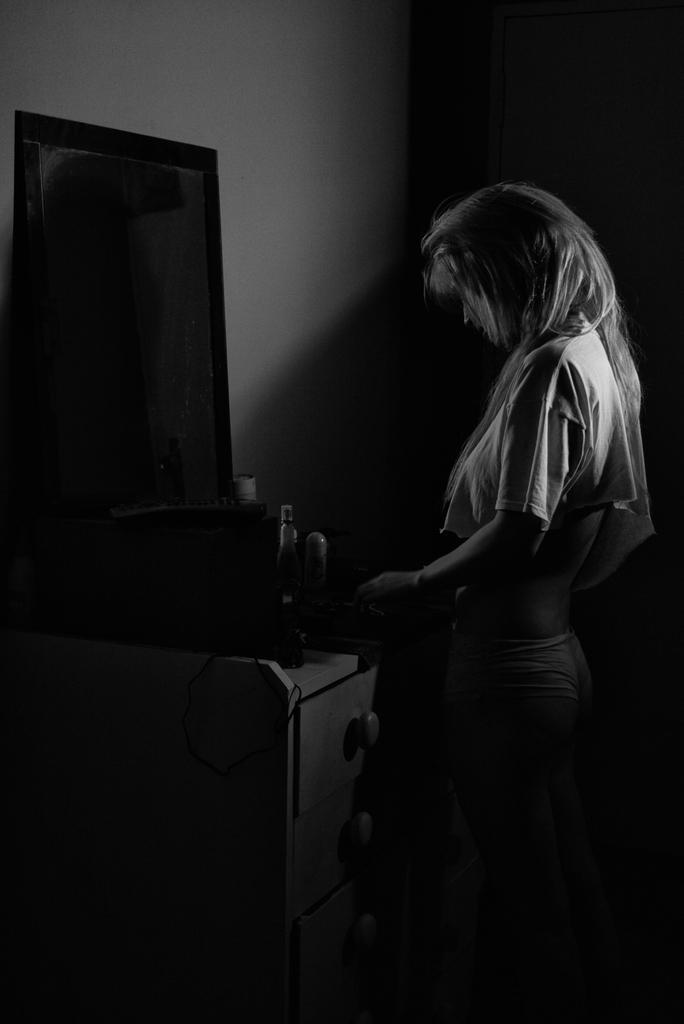Could you give a brief overview of what you see in this image? In the foreground of this black and white image, on the right, there is a woman standing in front of a dressing table on which, there are few objects and drawers to the table. In the background, there is the wall. 